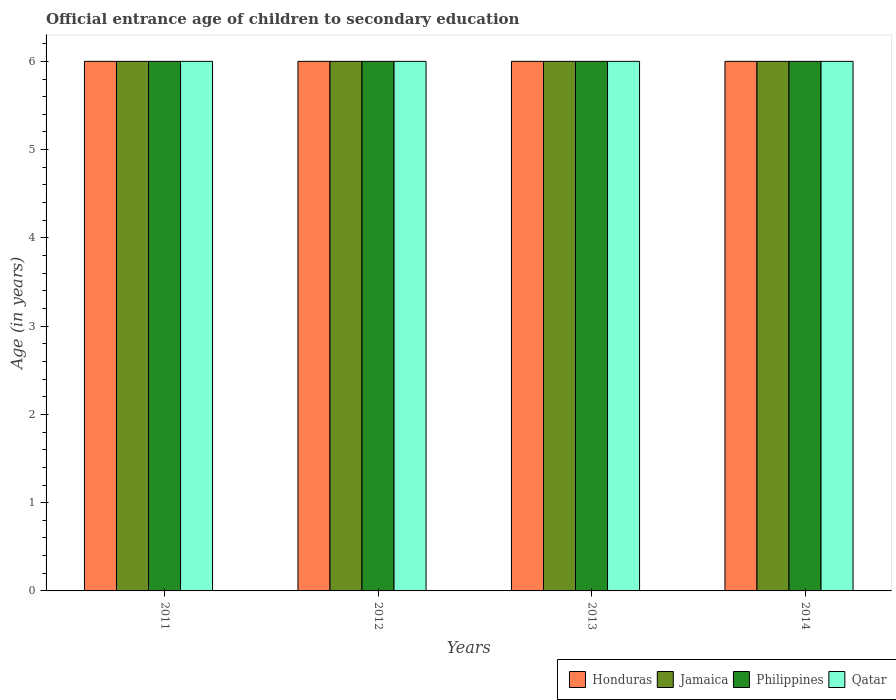How many different coloured bars are there?
Ensure brevity in your answer.  4. How many groups of bars are there?
Offer a very short reply. 4. Are the number of bars per tick equal to the number of legend labels?
Keep it short and to the point. Yes. Are the number of bars on each tick of the X-axis equal?
Your response must be concise. Yes. How many bars are there on the 4th tick from the left?
Keep it short and to the point. 4. What is the label of the 1st group of bars from the left?
Your answer should be compact. 2011. In how many cases, is the number of bars for a given year not equal to the number of legend labels?
Your answer should be very brief. 0. In which year was the secondary school starting age of children in Jamaica maximum?
Ensure brevity in your answer.  2011. What is the total secondary school starting age of children in Jamaica in the graph?
Ensure brevity in your answer.  24. What is the difference between the secondary school starting age of children in Qatar in 2011 and the secondary school starting age of children in Philippines in 2014?
Ensure brevity in your answer.  0. What is the average secondary school starting age of children in Qatar per year?
Offer a very short reply. 6. In how many years, is the secondary school starting age of children in Jamaica greater than 5.4 years?
Your answer should be very brief. 4. What is the ratio of the secondary school starting age of children in Qatar in 2012 to that in 2013?
Offer a terse response. 1. Is the difference between the secondary school starting age of children in Honduras in 2012 and 2013 greater than the difference between the secondary school starting age of children in Jamaica in 2012 and 2013?
Give a very brief answer. No. What is the difference between the highest and the lowest secondary school starting age of children in Philippines?
Keep it short and to the point. 0. Is it the case that in every year, the sum of the secondary school starting age of children in Qatar and secondary school starting age of children in Philippines is greater than the sum of secondary school starting age of children in Honduras and secondary school starting age of children in Jamaica?
Keep it short and to the point. No. What does the 2nd bar from the left in 2013 represents?
Keep it short and to the point. Jamaica. What does the 1st bar from the right in 2012 represents?
Make the answer very short. Qatar. Is it the case that in every year, the sum of the secondary school starting age of children in Honduras and secondary school starting age of children in Jamaica is greater than the secondary school starting age of children in Qatar?
Ensure brevity in your answer.  Yes. What is the difference between two consecutive major ticks on the Y-axis?
Offer a terse response. 1. Are the values on the major ticks of Y-axis written in scientific E-notation?
Ensure brevity in your answer.  No. Where does the legend appear in the graph?
Your answer should be very brief. Bottom right. What is the title of the graph?
Your response must be concise. Official entrance age of children to secondary education. What is the label or title of the Y-axis?
Your response must be concise. Age (in years). What is the Age (in years) in Honduras in 2011?
Your response must be concise. 6. What is the Age (in years) of Jamaica in 2011?
Make the answer very short. 6. What is the Age (in years) of Qatar in 2011?
Your answer should be compact. 6. What is the Age (in years) in Honduras in 2012?
Ensure brevity in your answer.  6. What is the Age (in years) of Jamaica in 2012?
Offer a very short reply. 6. What is the Age (in years) of Philippines in 2013?
Provide a short and direct response. 6. What is the Age (in years) in Honduras in 2014?
Offer a terse response. 6. What is the Age (in years) of Philippines in 2014?
Ensure brevity in your answer.  6. Across all years, what is the maximum Age (in years) in Jamaica?
Your answer should be compact. 6. Across all years, what is the minimum Age (in years) of Jamaica?
Your response must be concise. 6. Across all years, what is the minimum Age (in years) in Philippines?
Give a very brief answer. 6. Across all years, what is the minimum Age (in years) of Qatar?
Your answer should be very brief. 6. What is the total Age (in years) of Jamaica in the graph?
Offer a very short reply. 24. What is the difference between the Age (in years) of Jamaica in 2011 and that in 2012?
Make the answer very short. 0. What is the difference between the Age (in years) in Philippines in 2011 and that in 2013?
Give a very brief answer. 0. What is the difference between the Age (in years) in Philippines in 2011 and that in 2014?
Your answer should be compact. 0. What is the difference between the Age (in years) in Qatar in 2011 and that in 2014?
Provide a short and direct response. 0. What is the difference between the Age (in years) of Honduras in 2012 and that in 2013?
Make the answer very short. 0. What is the difference between the Age (in years) of Jamaica in 2012 and that in 2013?
Your answer should be very brief. 0. What is the difference between the Age (in years) of Philippines in 2012 and that in 2013?
Provide a short and direct response. 0. What is the difference between the Age (in years) of Qatar in 2012 and that in 2013?
Provide a succinct answer. 0. What is the difference between the Age (in years) in Philippines in 2012 and that in 2014?
Offer a terse response. 0. What is the difference between the Age (in years) of Qatar in 2012 and that in 2014?
Your answer should be very brief. 0. What is the difference between the Age (in years) in Honduras in 2011 and the Age (in years) in Philippines in 2012?
Your response must be concise. 0. What is the difference between the Age (in years) in Honduras in 2011 and the Age (in years) in Qatar in 2012?
Make the answer very short. 0. What is the difference between the Age (in years) of Jamaica in 2011 and the Age (in years) of Philippines in 2012?
Keep it short and to the point. 0. What is the difference between the Age (in years) in Jamaica in 2011 and the Age (in years) in Qatar in 2012?
Provide a succinct answer. 0. What is the difference between the Age (in years) in Honduras in 2011 and the Age (in years) in Jamaica in 2013?
Make the answer very short. 0. What is the difference between the Age (in years) of Honduras in 2011 and the Age (in years) of Qatar in 2013?
Your answer should be very brief. 0. What is the difference between the Age (in years) of Jamaica in 2011 and the Age (in years) of Philippines in 2013?
Offer a terse response. 0. What is the difference between the Age (in years) of Honduras in 2011 and the Age (in years) of Philippines in 2014?
Your answer should be compact. 0. What is the difference between the Age (in years) in Jamaica in 2011 and the Age (in years) in Philippines in 2014?
Provide a short and direct response. 0. What is the difference between the Age (in years) in Philippines in 2011 and the Age (in years) in Qatar in 2014?
Provide a succinct answer. 0. What is the difference between the Age (in years) of Honduras in 2012 and the Age (in years) of Jamaica in 2013?
Your answer should be compact. 0. What is the difference between the Age (in years) of Jamaica in 2012 and the Age (in years) of Philippines in 2013?
Make the answer very short. 0. What is the difference between the Age (in years) of Philippines in 2012 and the Age (in years) of Qatar in 2014?
Provide a short and direct response. 0. What is the difference between the Age (in years) in Honduras in 2013 and the Age (in years) in Philippines in 2014?
Your answer should be compact. 0. What is the difference between the Age (in years) of Jamaica in 2013 and the Age (in years) of Qatar in 2014?
Keep it short and to the point. 0. What is the average Age (in years) of Honduras per year?
Offer a very short reply. 6. What is the average Age (in years) in Philippines per year?
Ensure brevity in your answer.  6. In the year 2011, what is the difference between the Age (in years) in Honduras and Age (in years) in Philippines?
Your answer should be compact. 0. In the year 2011, what is the difference between the Age (in years) in Jamaica and Age (in years) in Philippines?
Provide a succinct answer. 0. In the year 2011, what is the difference between the Age (in years) in Jamaica and Age (in years) in Qatar?
Your response must be concise. 0. In the year 2011, what is the difference between the Age (in years) in Philippines and Age (in years) in Qatar?
Your response must be concise. 0. In the year 2012, what is the difference between the Age (in years) of Honduras and Age (in years) of Qatar?
Give a very brief answer. 0. In the year 2012, what is the difference between the Age (in years) of Jamaica and Age (in years) of Qatar?
Offer a terse response. 0. In the year 2013, what is the difference between the Age (in years) in Honduras and Age (in years) in Qatar?
Provide a short and direct response. 0. In the year 2013, what is the difference between the Age (in years) of Jamaica and Age (in years) of Qatar?
Provide a short and direct response. 0. In the year 2013, what is the difference between the Age (in years) in Philippines and Age (in years) in Qatar?
Your response must be concise. 0. In the year 2014, what is the difference between the Age (in years) of Honduras and Age (in years) of Jamaica?
Keep it short and to the point. 0. In the year 2014, what is the difference between the Age (in years) in Honduras and Age (in years) in Qatar?
Give a very brief answer. 0. In the year 2014, what is the difference between the Age (in years) of Jamaica and Age (in years) of Philippines?
Your answer should be compact. 0. In the year 2014, what is the difference between the Age (in years) in Jamaica and Age (in years) in Qatar?
Make the answer very short. 0. In the year 2014, what is the difference between the Age (in years) in Philippines and Age (in years) in Qatar?
Make the answer very short. 0. What is the ratio of the Age (in years) of Jamaica in 2011 to that in 2012?
Provide a succinct answer. 1. What is the ratio of the Age (in years) of Philippines in 2011 to that in 2012?
Make the answer very short. 1. What is the ratio of the Age (in years) of Jamaica in 2011 to that in 2014?
Offer a very short reply. 1. What is the ratio of the Age (in years) of Qatar in 2011 to that in 2014?
Your answer should be very brief. 1. What is the ratio of the Age (in years) of Philippines in 2012 to that in 2013?
Make the answer very short. 1. What is the ratio of the Age (in years) in Qatar in 2012 to that in 2013?
Offer a very short reply. 1. What is the ratio of the Age (in years) in Philippines in 2012 to that in 2014?
Your answer should be compact. 1. What is the ratio of the Age (in years) of Honduras in 2013 to that in 2014?
Your answer should be compact. 1. What is the ratio of the Age (in years) in Philippines in 2013 to that in 2014?
Keep it short and to the point. 1. What is the difference between the highest and the second highest Age (in years) of Honduras?
Make the answer very short. 0. What is the difference between the highest and the second highest Age (in years) of Philippines?
Provide a short and direct response. 0. What is the difference between the highest and the second highest Age (in years) of Qatar?
Offer a very short reply. 0. 